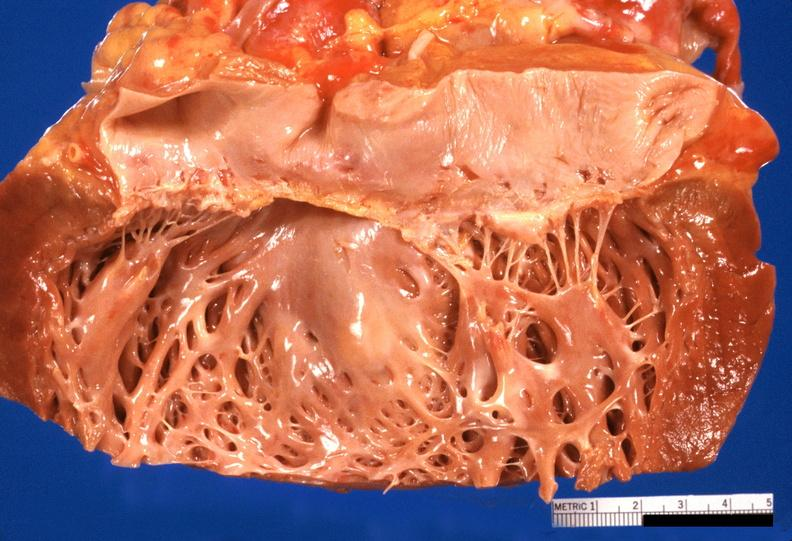what is present?
Answer the question using a single word or phrase. Cardiovascular 